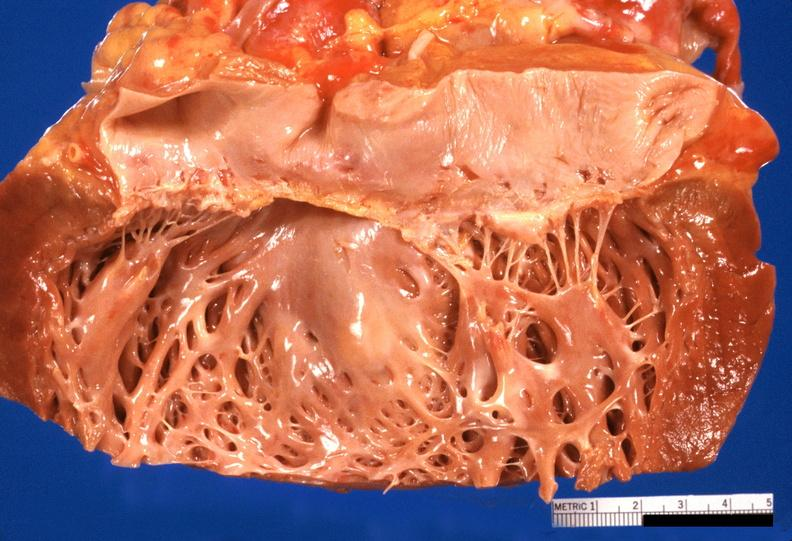what is present?
Answer the question using a single word or phrase. Cardiovascular 